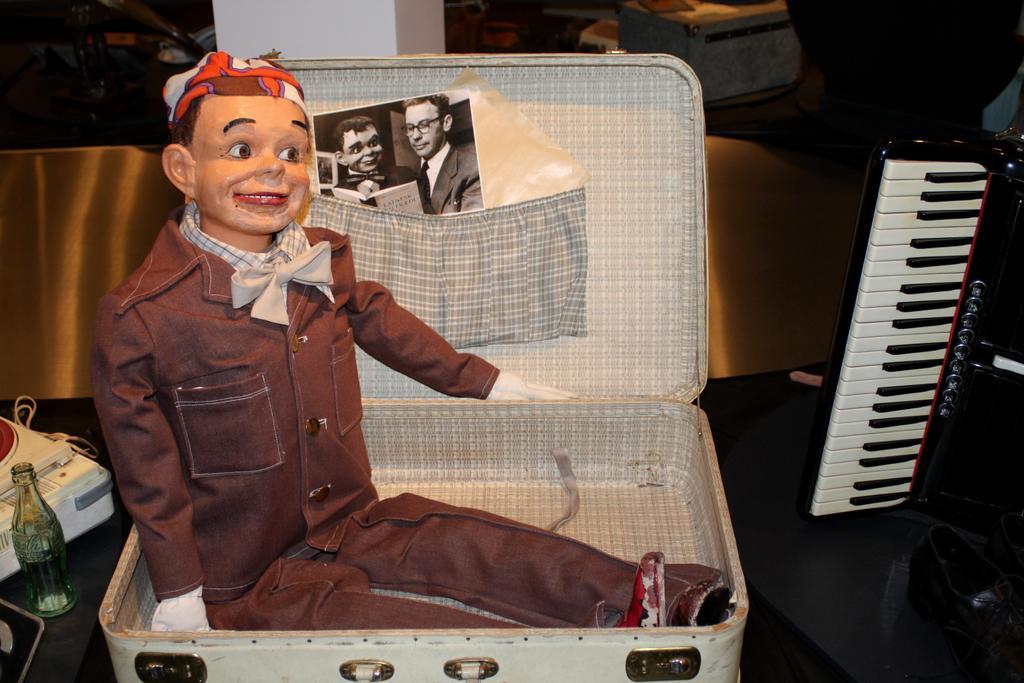In one or two sentences, can you explain what this image depicts? He is sitting on the suitcase. His wearing coat and tie. His smiling. We can in the background there is a cool drink bottle,pillar,bags and musical keyboard. 